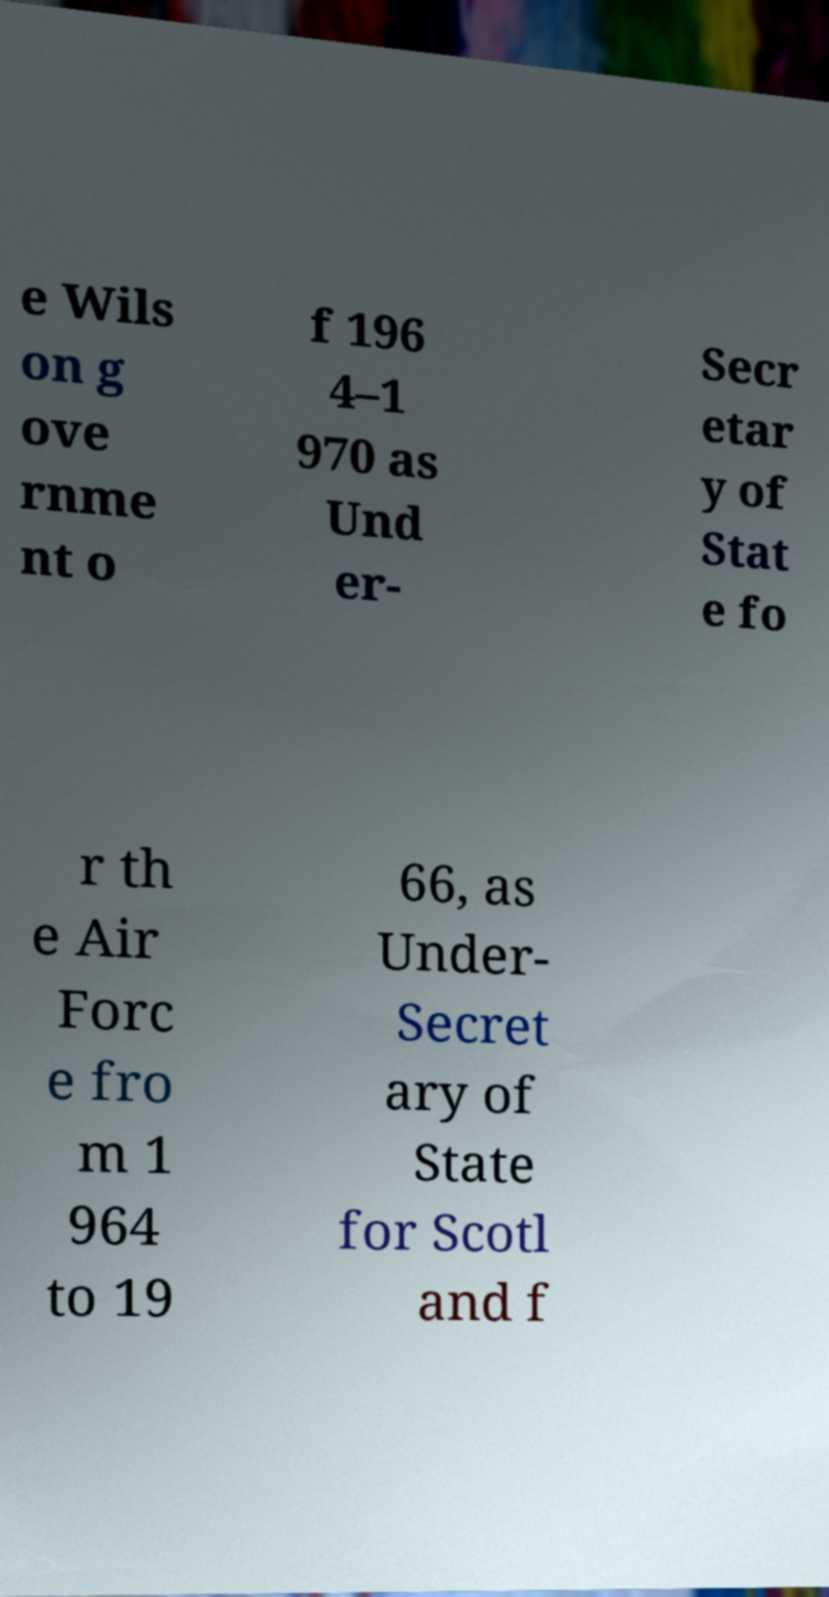Could you extract and type out the text from this image? e Wils on g ove rnme nt o f 196 4–1 970 as Und er- Secr etar y of Stat e fo r th e Air Forc e fro m 1 964 to 19 66, as Under- Secret ary of State for Scotl and f 